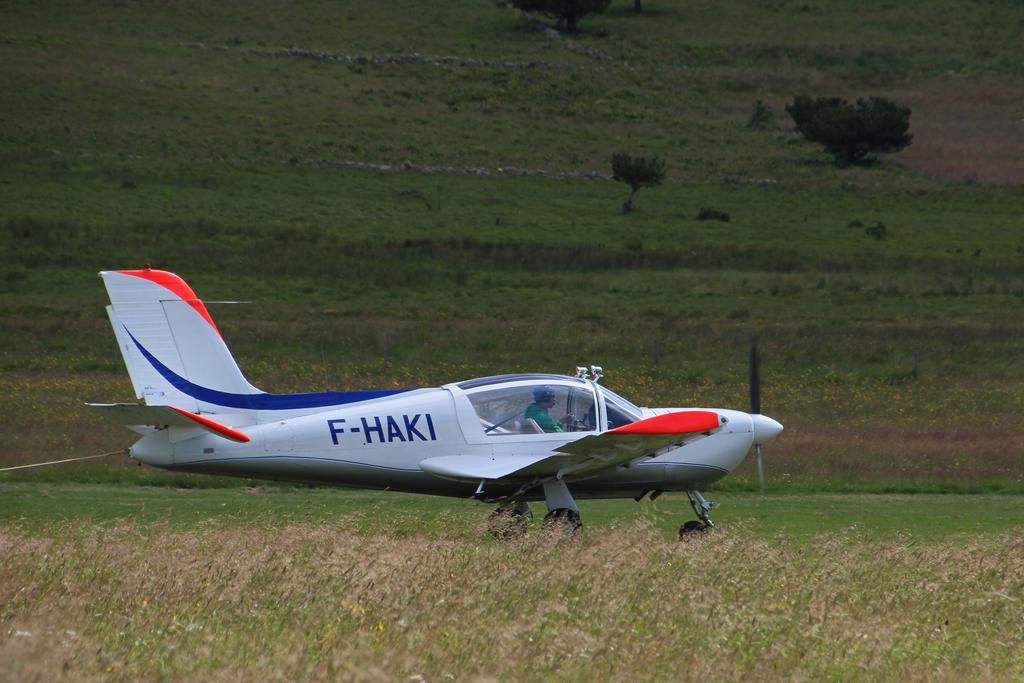Please provide a concise description of this image. As we can see in the image there is a dry grass, a person sitting in plane and in the background there is a tree. 